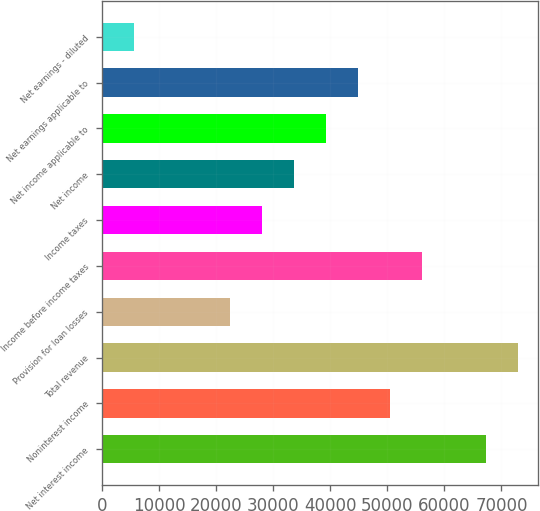Convert chart. <chart><loc_0><loc_0><loc_500><loc_500><bar_chart><fcel>Net interest income<fcel>Noninterest income<fcel>Total revenue<fcel>Provision for loan losses<fcel>Income before income taxes<fcel>Income taxes<fcel>Net income<fcel>Net income applicable to<fcel>Net earnings applicable to<fcel>Net earnings - diluted<nl><fcel>67225.2<fcel>50418.9<fcel>72827.3<fcel>22408.5<fcel>56021<fcel>28010.6<fcel>33612.7<fcel>39214.8<fcel>44816.8<fcel>5602.22<nl></chart> 